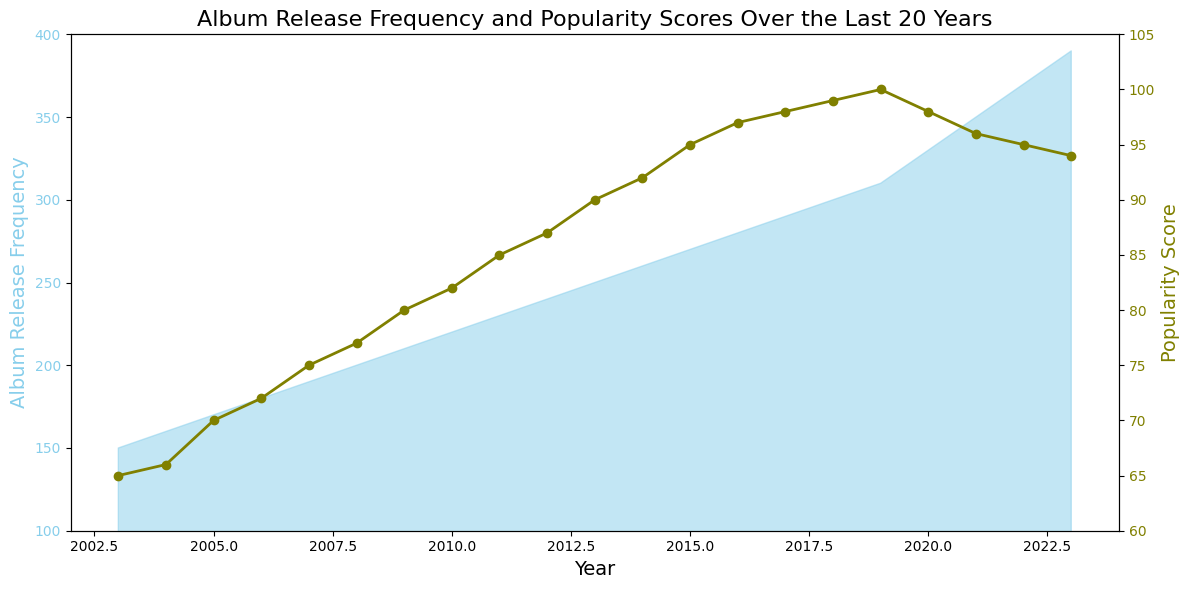What's the trend in album release frequency from 2003 to 2023? The album release frequency shows a consistent upward trend. Starting at 150 in 2003, it steadily increases each year, reaching 390 by 2023.
Answer: Increasing In which year did the popularity score reach its peak? The popularity score reaches its peak in 2019 with a value of 100. This can be seen as it is the highest point on the line representing the popularity score.
Answer: 2019 How does the popularity score change from 2019 to 2023? From 2019 to 2023, the popularity score shows a decreasing trend. The score was 100 in 2019 and gradually decreased to 94 by 2023.
Answer: Decreasing Which year shows the greatest increase in album release frequency compared to the previous year? The largest annual increase can be observed between 2019 and 2020, where the album release frequency jumps from 310 to 330, an increase of 20.
Answer: 2020 How does the album release frequency in 2023 compare to that in 2003? The album release frequency in 2023 (390) is significantly higher than in 2003 (150). The frequency has increased by 240 over the 20-year period.
Answer: Greater Were there any years with a decline in the popularity score? If so, which ones? Yes, there were declines in the popularity score. The years where the popularity score declined compared to the previous year are 2020, 2021, 2022, and 2023.
Answer: 2020, 2021, 2022, 2023 What is the average popularity score over the 20 years shown in the chart? To find the average, sum all the popularity scores from 2003 to 2023 and divide by the number of years (21). The sum of the scores is 1746, and the average is 1746 / 21 ≈ 83.14.
Answer: 83.14 By how much did the popularity score change from the lowest point on the graph to the highest point? The lowest popularity score is 65 in 2003, and the highest is 100 in 2019. The change in the popularity score is 100 - 65 = 35.
Answer: 35 Approximately what was the album release frequency in 2016, and how did it compare to the popularity score in the same year? In 2016, the album release frequency was 280, and the popularity score was 97. This indicates that as the album release frequency increased, the popularity score was also relatively high.
Answer: 280, 97 